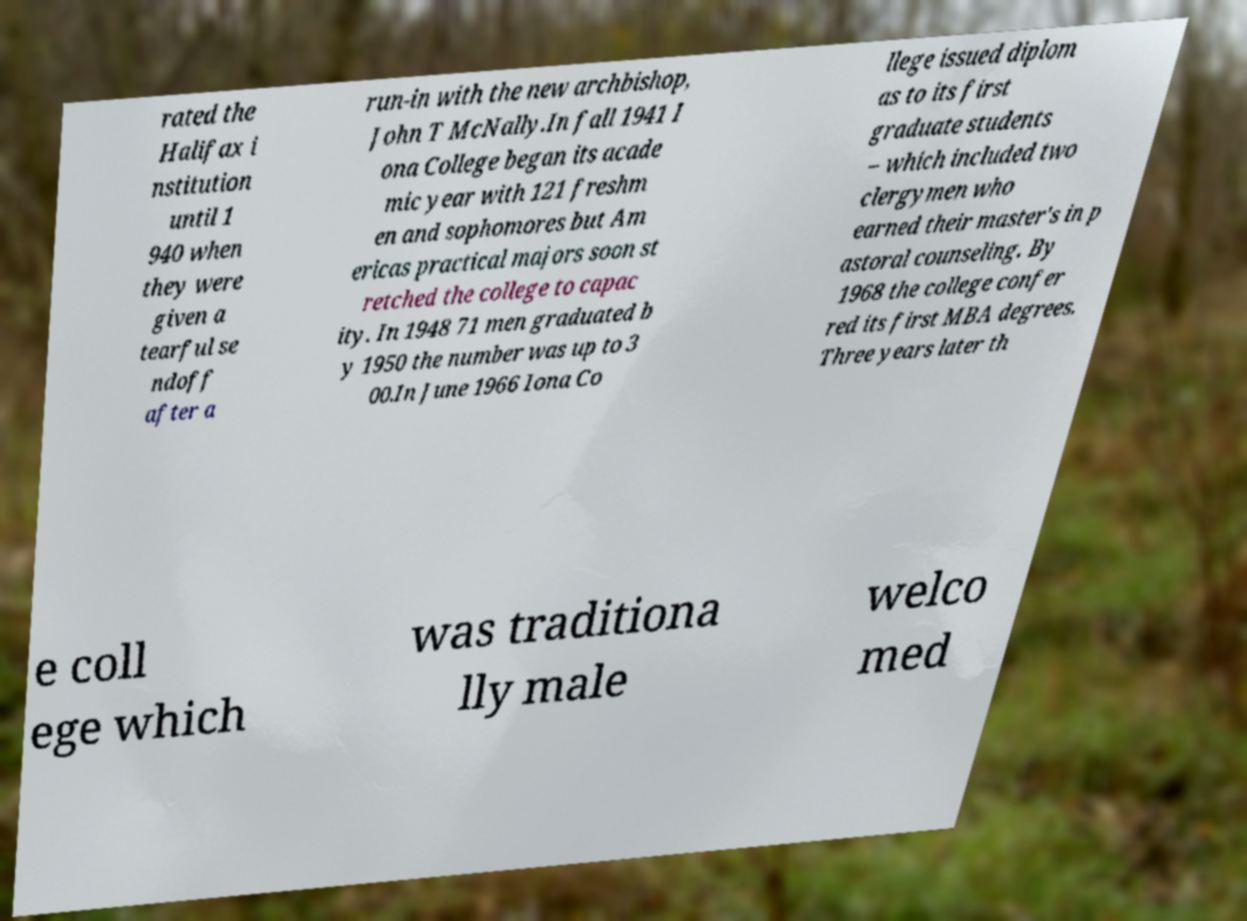What messages or text are displayed in this image? I need them in a readable, typed format. rated the Halifax i nstitution until 1 940 when they were given a tearful se ndoff after a run-in with the new archbishop, John T McNally.In fall 1941 I ona College began its acade mic year with 121 freshm en and sophomores but Am ericas practical majors soon st retched the college to capac ity. In 1948 71 men graduated b y 1950 the number was up to 3 00.In June 1966 Iona Co llege issued diplom as to its first graduate students – which included two clergymen who earned their master's in p astoral counseling. By 1968 the college confer red its first MBA degrees. Three years later th e coll ege which was traditiona lly male welco med 